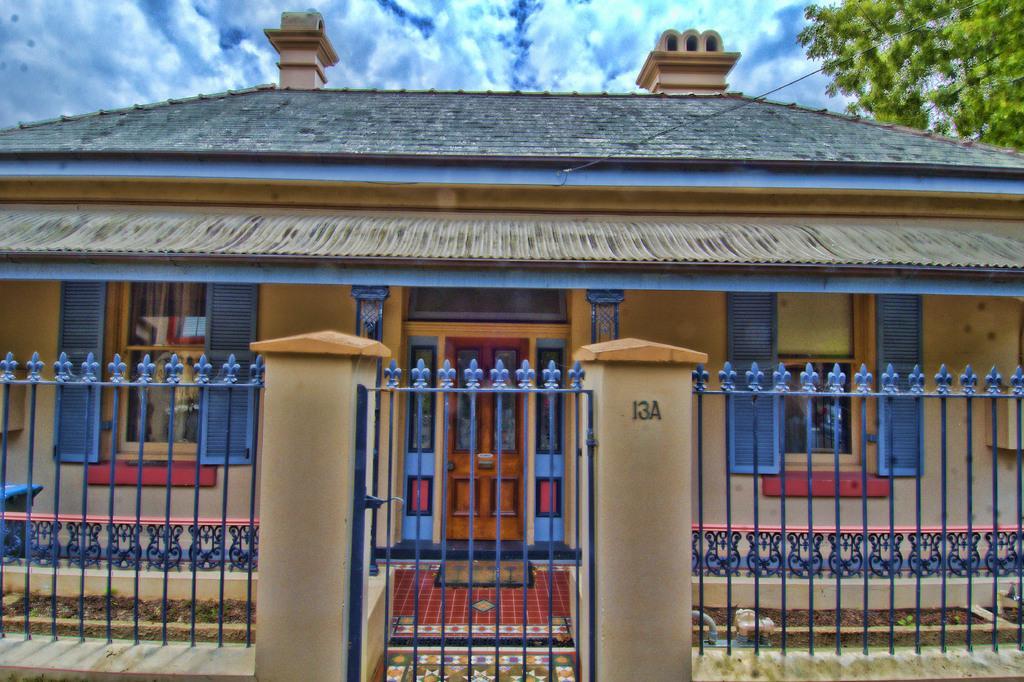How would you summarize this image in a sentence or two? In this image there is one house in middle of this image and there is one house in middle of this image. There is a tree at top right corner of this image and there is a cloudy sky at top of this image. There are some gates at bottom of this image. 